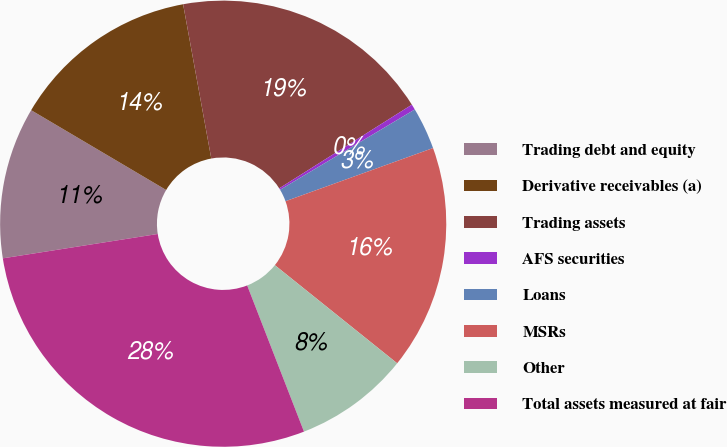<chart> <loc_0><loc_0><loc_500><loc_500><pie_chart><fcel>Trading debt and equity<fcel>Derivative receivables (a)<fcel>Trading assets<fcel>AFS securities<fcel>Loans<fcel>MSRs<fcel>Other<fcel>Total assets measured at fair<nl><fcel>10.98%<fcel>13.63%<fcel>18.92%<fcel>0.4%<fcel>3.05%<fcel>16.27%<fcel>8.34%<fcel>28.42%<nl></chart> 